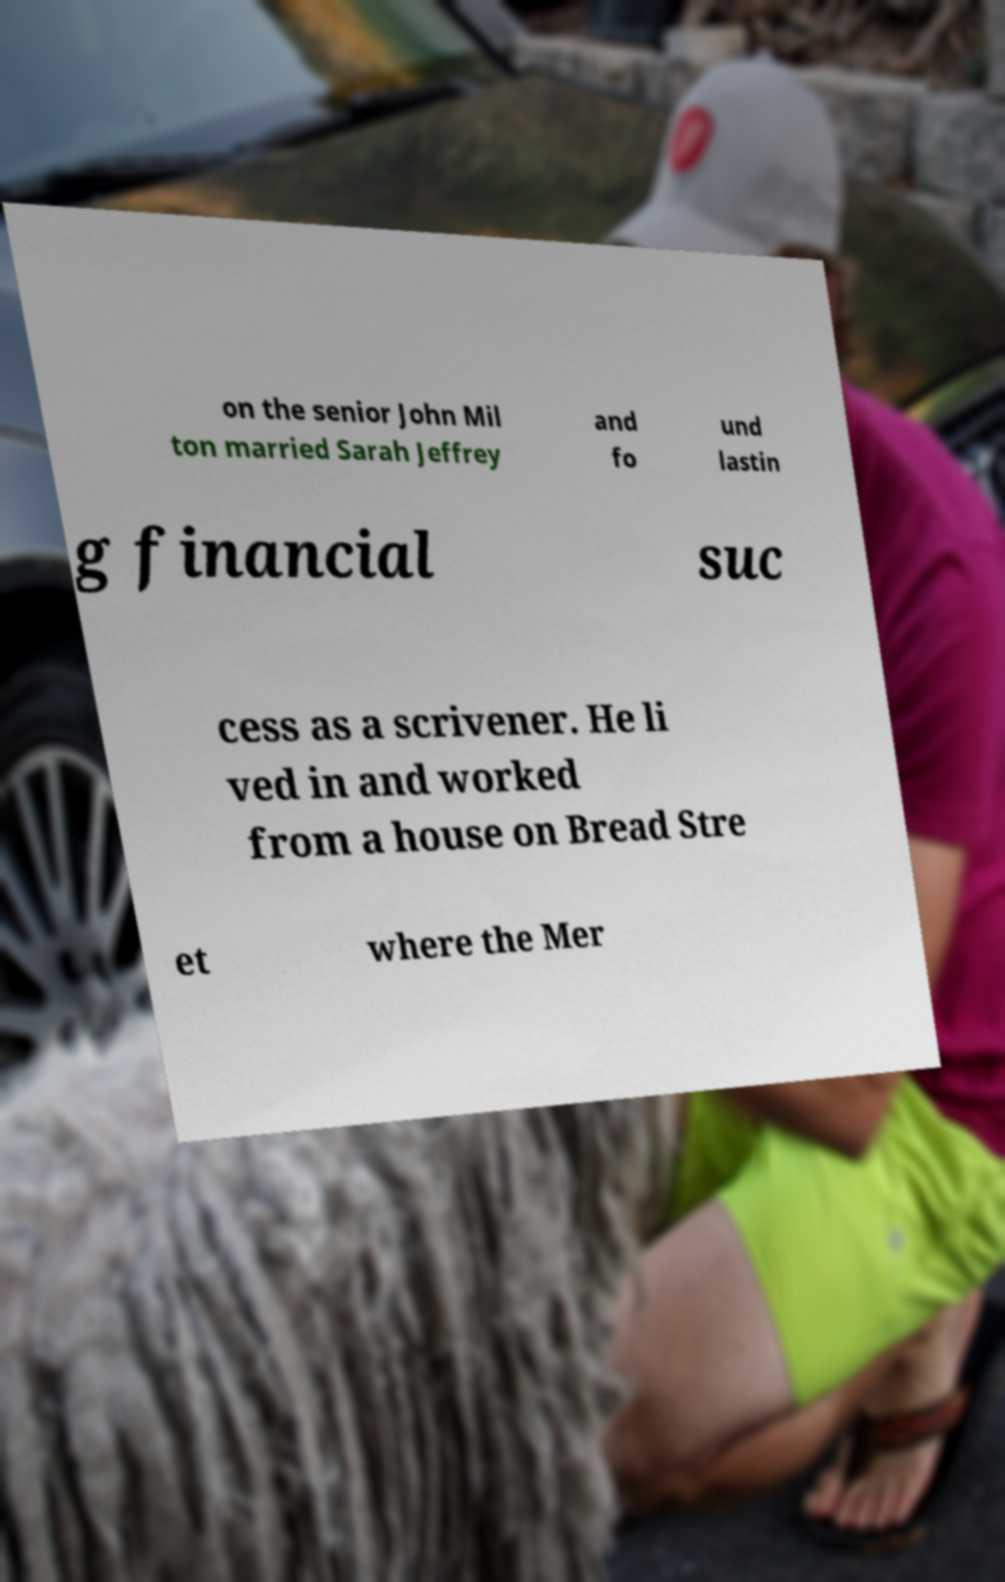For documentation purposes, I need the text within this image transcribed. Could you provide that? on the senior John Mil ton married Sarah Jeffrey and fo und lastin g financial suc cess as a scrivener. He li ved in and worked from a house on Bread Stre et where the Mer 